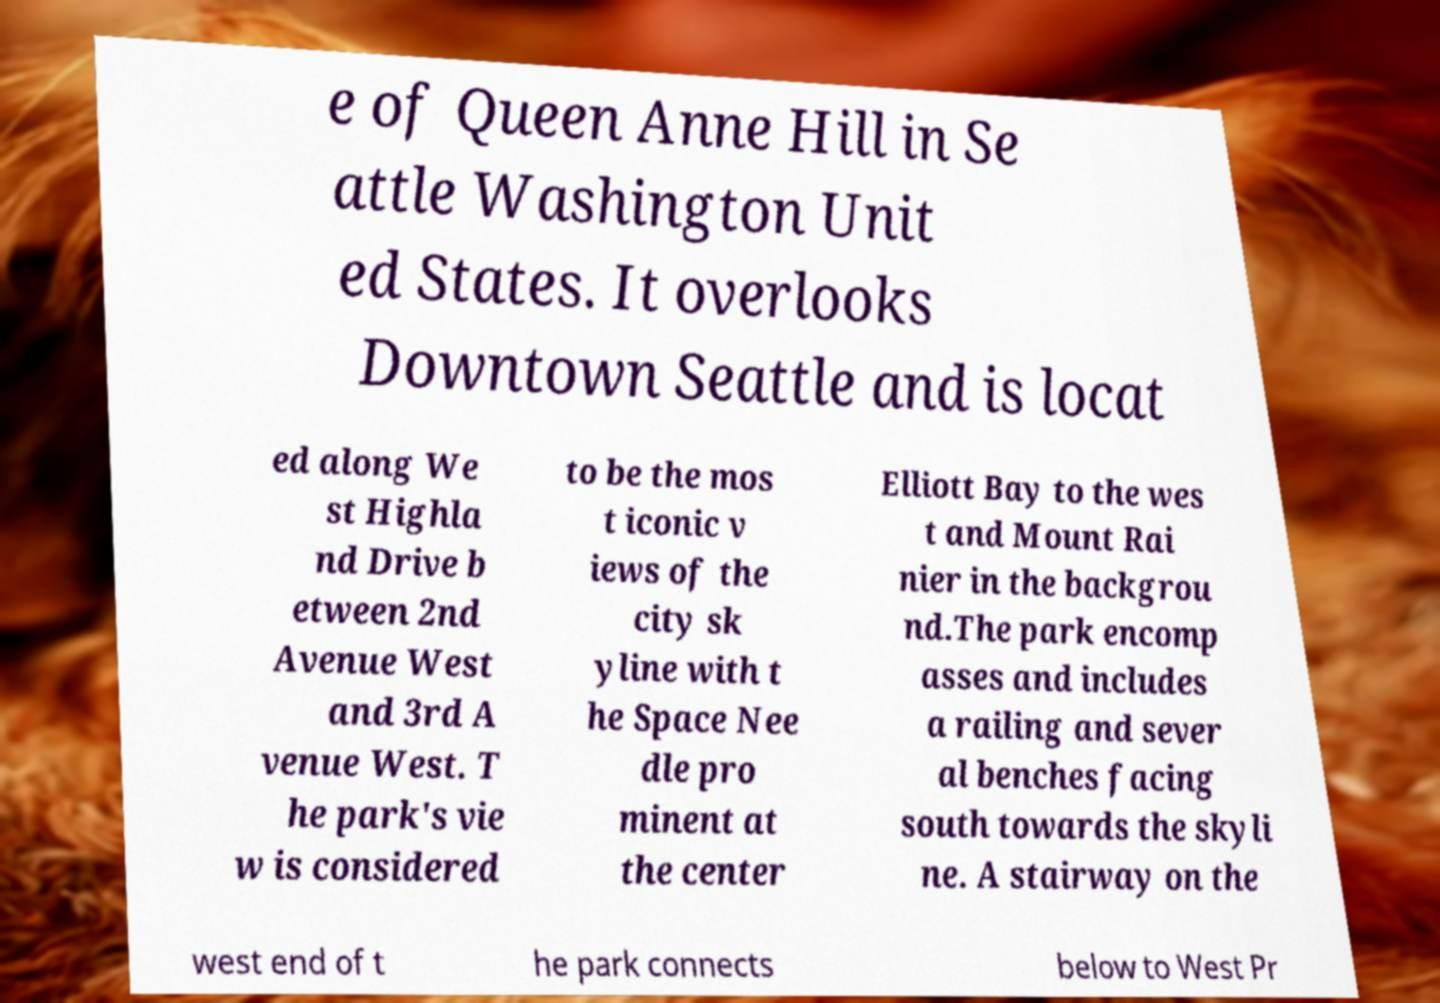Could you assist in decoding the text presented in this image and type it out clearly? e of Queen Anne Hill in Se attle Washington Unit ed States. It overlooks Downtown Seattle and is locat ed along We st Highla nd Drive b etween 2nd Avenue West and 3rd A venue West. T he park's vie w is considered to be the mos t iconic v iews of the city sk yline with t he Space Nee dle pro minent at the center Elliott Bay to the wes t and Mount Rai nier in the backgrou nd.The park encomp asses and includes a railing and sever al benches facing south towards the skyli ne. A stairway on the west end of t he park connects below to West Pr 